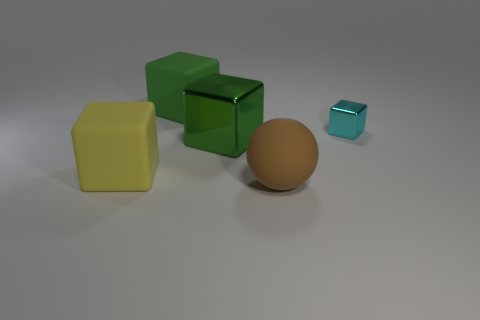Add 1 big brown rubber cubes. How many objects exist? 6 Subtract all large yellow matte cubes. How many cubes are left? 3 Subtract all cyan blocks. How many blocks are left? 3 Subtract 1 blocks. How many blocks are left? 3 Subtract all cyan blocks. Subtract all large green matte blocks. How many objects are left? 3 Add 3 tiny cyan metallic blocks. How many tiny cyan metallic blocks are left? 4 Add 1 cyan things. How many cyan things exist? 2 Subtract 0 brown cubes. How many objects are left? 5 Subtract all blocks. How many objects are left? 1 Subtract all purple blocks. Subtract all brown spheres. How many blocks are left? 4 